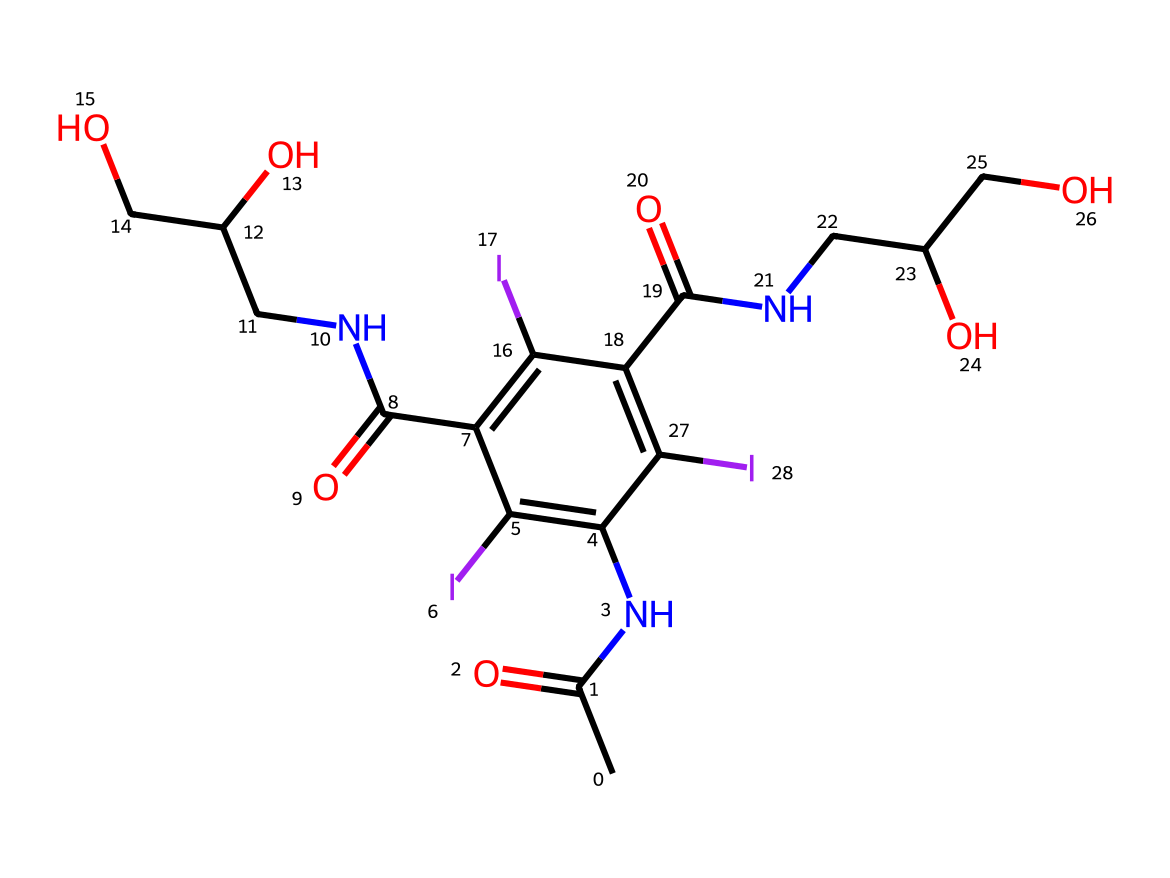What is the molecular formula of this compound? To determine the molecular formula, we need to count the number of each type of atom in the SMILES. Analyzing the SMILES reveals there are 15 carbon atoms, 18 hydrogen atoms, 3 nitrogen atoms, and 4 iodine atoms. Therefore, the molecular formula is C15H18N3I4.
Answer: C15H18N3I4 How many iodine atoms are present in the structure? The SMILES representation lists four iodine atoms explicitly. By carefully examining the individual components of the SMILES, we see 'I' appears four times, confirming the presence of four iodine atoms.
Answer: 4 What type of bonds are primarily found in the iodine substituents of this molecule? The iodine substituents in this chemical are bonded through single bonds to the aromatic carbon atoms. This can be inferred from the structure where iodine atoms are directly connected to carbon without any indication of double bonds.
Answer: single bonds What is the functional group indicated by 'N' in this structure? The presence of 'N' typically indicates the presence of amide functional groups, which are characterized by a carbonyl group (C=O) directly bonded to a nitrogen atom. The SMILES shows 'N' adjacent to carbon and oxygen, confirming it is indeed an amide.
Answer: amide How does the presence of iodine affect the properties of this compound as a contrast agent? Iodine enhances the radiopacity of this compound, allowing it to absorb X-rays more effectively. The reasoning is based on iodine's heavy atomic weight and its ability to increase contrast in medical imaging, which is crucial for diagnostically useful imaging techniques.
Answer: increases radiopacity What is the role of iodine in this compound related to its medical imaging function? Iodine in contrast agents serves to enhance visibility by absorbing the X-rays during imaging procedures. This function is critical as it provides better delineation of tissues and organs during diagnostic imaging, allowing for clearer visuals for physicians.
Answer: enhances visibility 